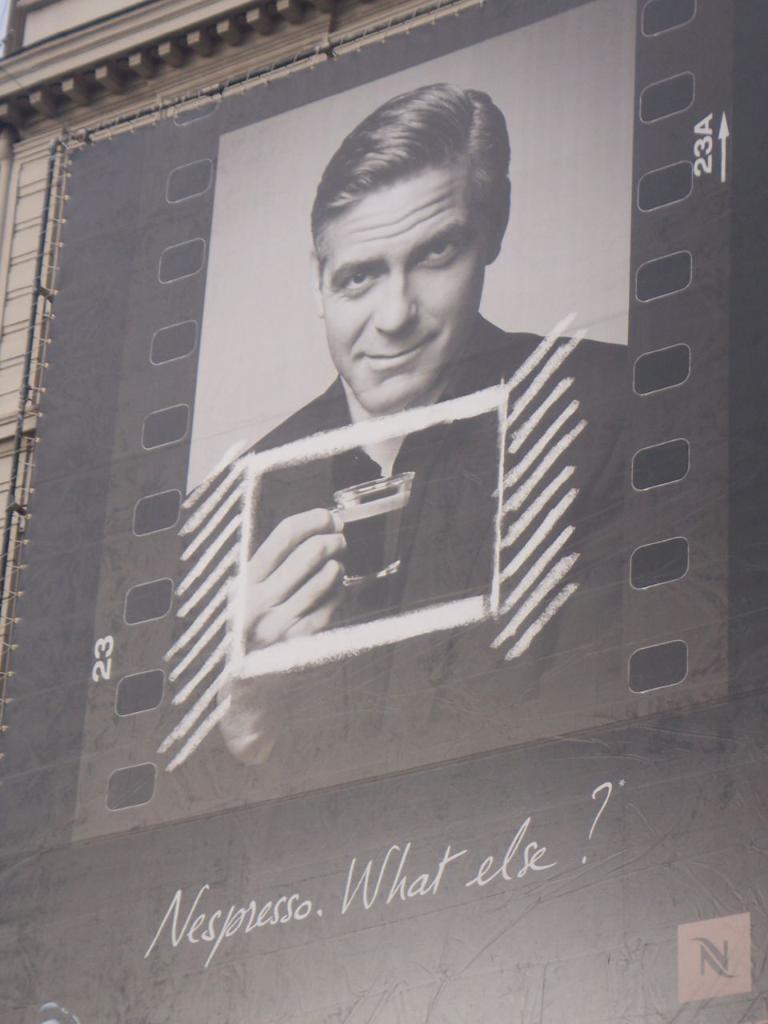In one or two sentences, can you explain what this image depicts? In this image we can see a poster which is attached to the building in which there is a person wearing black color suit holding some coffee glass in his hands and there is some text. 